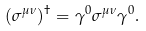<formula> <loc_0><loc_0><loc_500><loc_500>( \sigma ^ { \mu \nu } ) ^ { \dag } = \gamma ^ { 0 } \sigma ^ { \mu \nu } \gamma ^ { 0 } .</formula> 